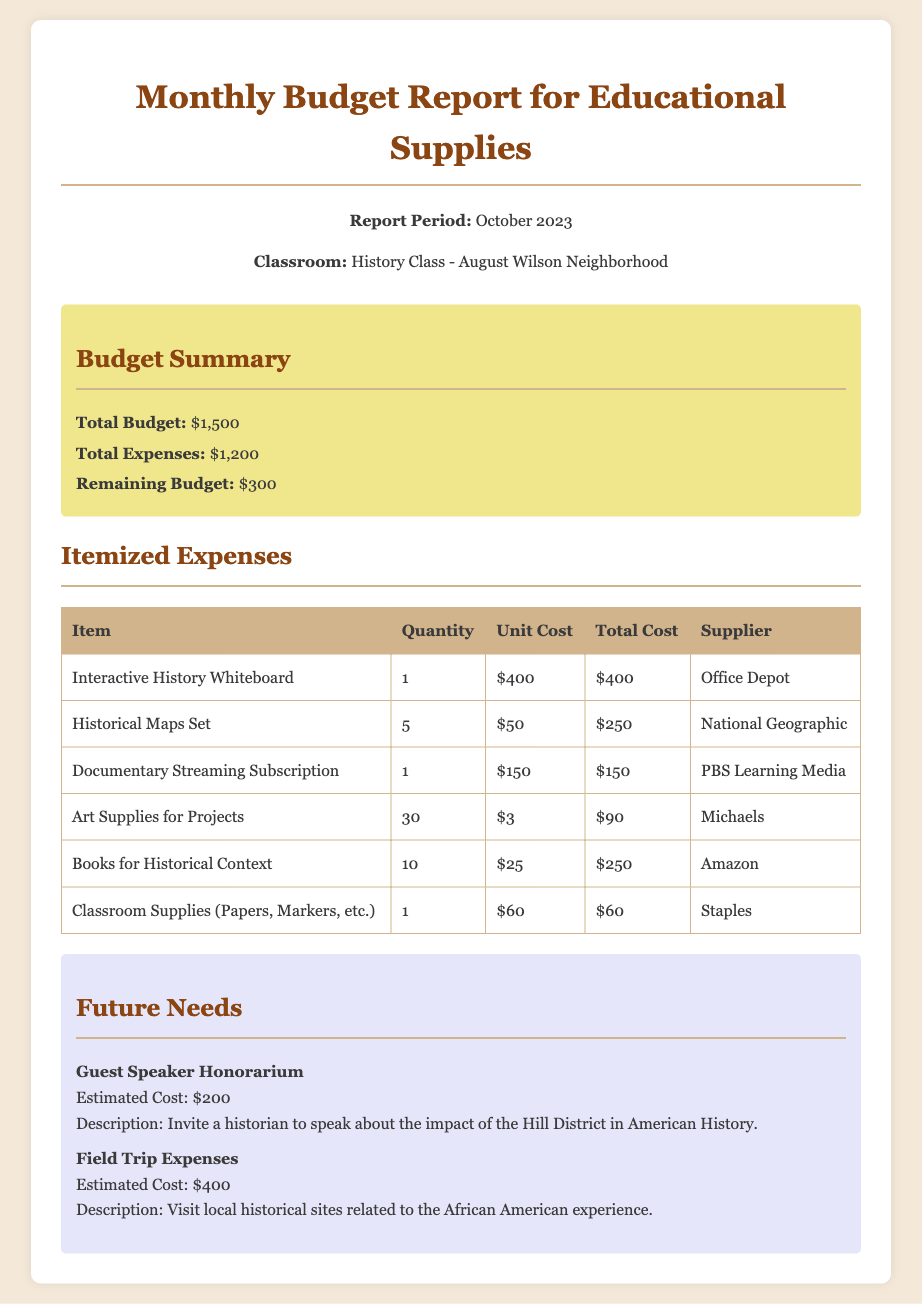What is the total budget? The total budget is stated in the budget summary section of the document, which shows $1,500.
Answer: $1,500 What is the total cost of the Interactive History Whiteboard? The document lists the total cost of the Interactive History Whiteboard as $400 in the itemized expenses table.
Answer: $400 How many books for historical context were purchased? The itemized expenses section indicates that 10 books for historical context were purchased.
Answer: 10 What is the estimated cost for the guest speaker honorarium? The future needs section provides the estimated cost for the guest speaker honorarium as $200.
Answer: $200 What is the remaining budget after expenses? The budget summary section calculates the remaining budget after expenses as $300.
Answer: $300 How many total art supplies were acquired? The itemized expenses details that 30 art supplies for projects were acquired.
Answer: 30 What is the supplier for the Historical Maps Set? According to the itemized expenses table, the supplier for the Historical Maps Set is National Geographic.
Answer: National Geographic What type of subscription was included in the expenses? The document specifies that a Documentary Streaming Subscription was included in the expenses.
Answer: Documentary Streaming Subscription What is the total amount spent on classroom supplies? The itemized expenses table shows that the total amount spent on classroom supplies is $60.
Answer: $60 